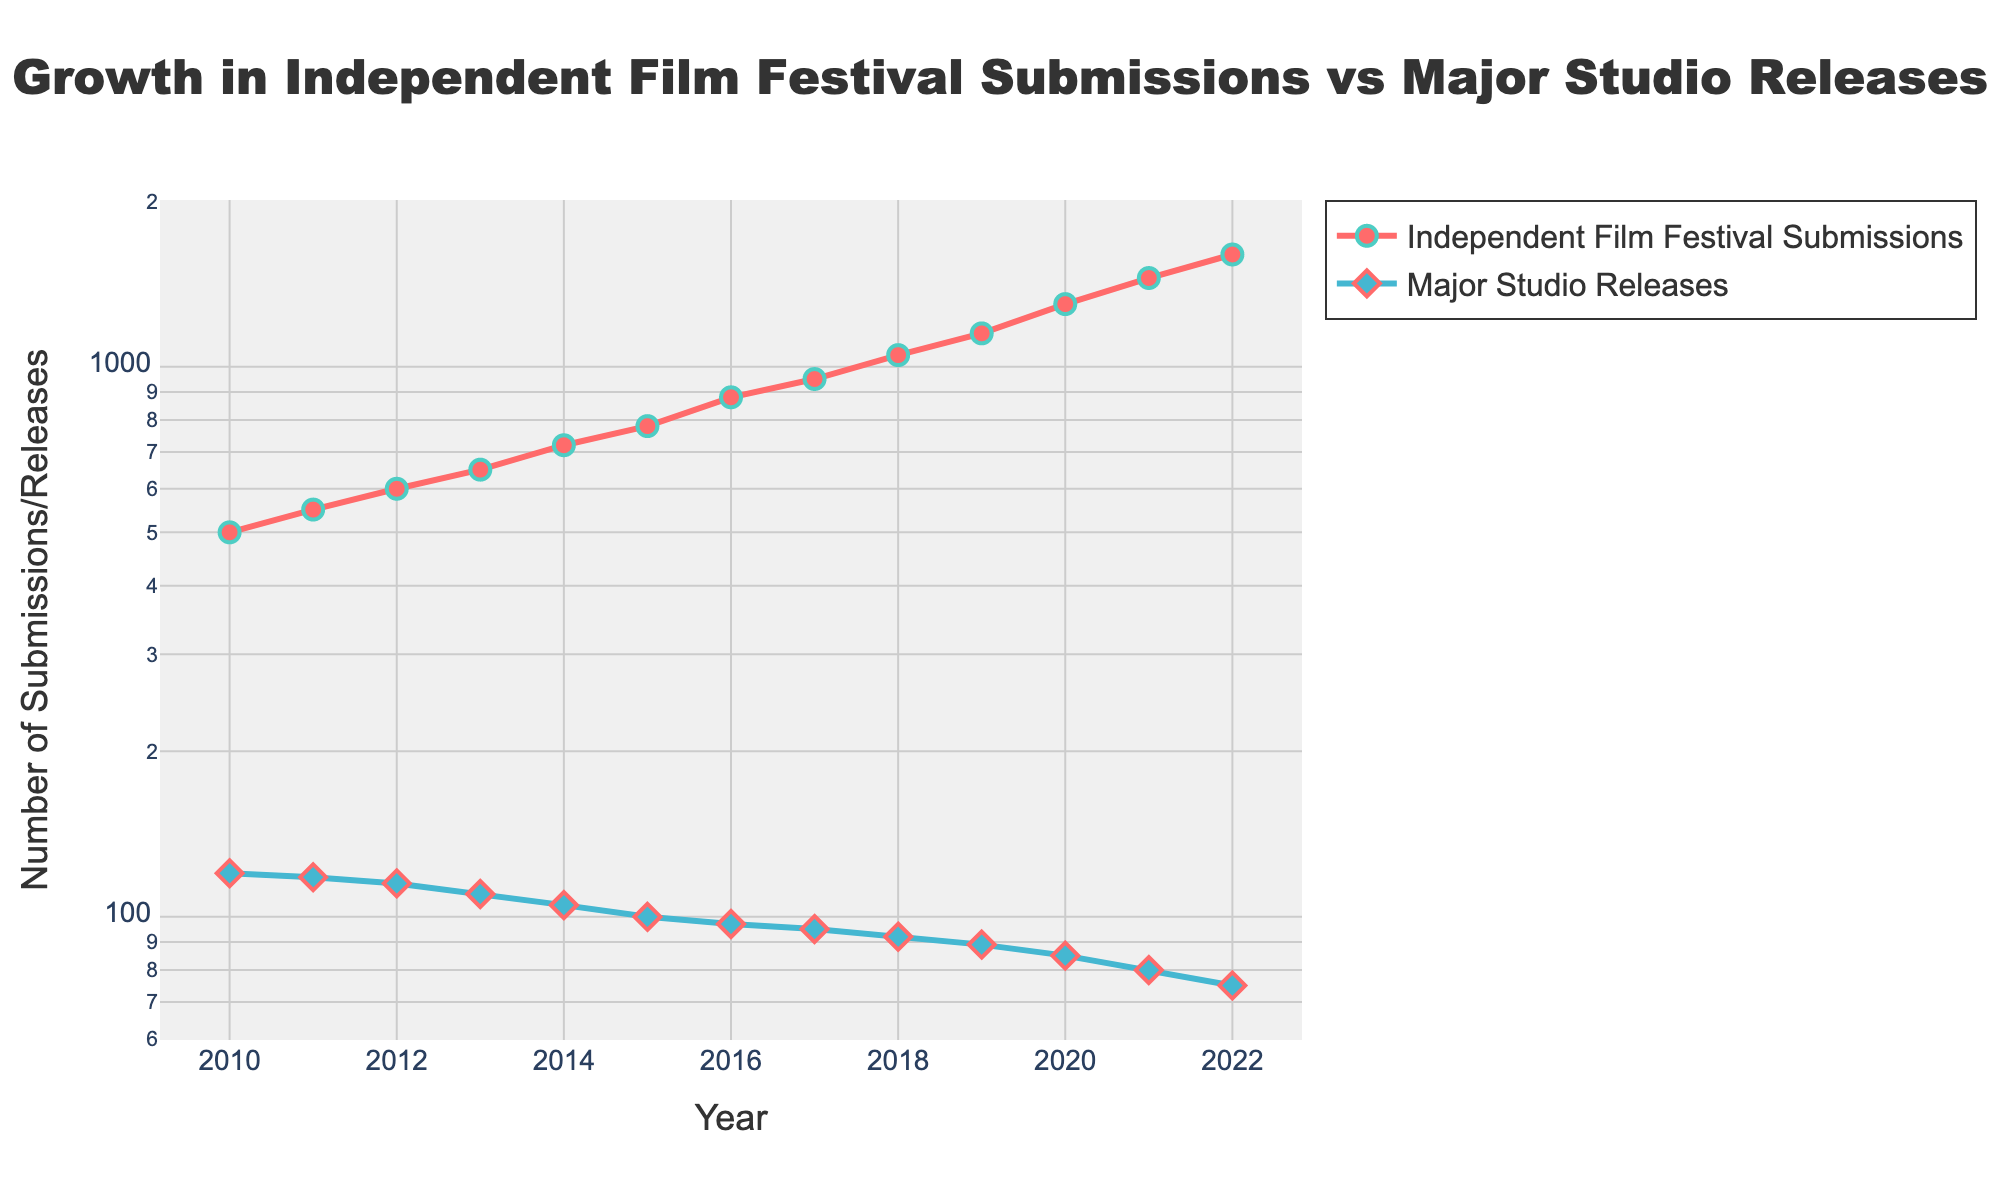How many data points represent the Independent Film Festival Submissions from 2010 to 2022? By counting the number of data points along the timeline from 2010 to 2022 for the Independent Film Festival Submissions, you can see there are 13 data points (one for each year).
Answer: 13 What color represents the Major Studio Releases in the plot? The color representing the Major Studio Releases is observed directly from the legend in the plot, which indicates a blue color.
Answer: Blue How does the number of submissions for Independent Film Festivals compare to Major Studio Releases in 2010? In the year 2010, the plot shows that Independent Film Festival Submissions are at 500, while Major Studio Releases are at 120, which means independent submissions are significantly higher.
Answer: Independent submissions are higher By what multiplicative factor did the Independent Film Festival Submissions increase from 2010 to 2022? To find the factor of increase, divide the data point of 2022 (1600 submissions) by the data point of 2010 (500 submissions). The calculation is 1600 ÷ 500 = 3.2.
Answer: 3.2 In which year did Major Studio Releases fall below 100? According to the plot, Major Studio Releases are below 100 starting from the year 2015.
Answer: 2015 What's the average annual increase in Independent Film Festival Submissions from 2010 to 2022? The total increase is found by subtracting 500 (2010) from 1600 (2022), resulting in 1100. There are 12 intervals (2022 - 2010), so the average increase per year is 1100 ÷ 12 ≈ 91.67.
Answer: 91.67 Which category shows a logarithmic scale increase in the y-axis? Observing the y-axis scale and the nature of exponential growth in the Independent Film Festival Submissions, it is evident that they are plotted on a logarithmic scale due to the exponential trend.
Answer: Independent Film Festival Submissions How much did Major Studio Releases decrease on average each year from 2010 to 2022? The total decrease is 120 (2010) - 75 (2022), which equals 45. Over 12 years, the average decrease per year is 45 ÷ 12 ≈ 3.75.
Answer: 3.75 Is there any year where the number of Major Studio Releases was equal to the number of Independent Film Festival Submissions? Checking each year on the plot, there is no instance where the number of Major Studio Releases equals the number of Independent Film Festival Submissions in any given year.
Answer: No What is the trend observed in the number of Independent Film Festival Submissions over the years 2010 to 2022? The trend for Independent Film Festival Submissions shows a consistent and exponential increase from 500 in 2010 to 1600 in 2022, indicating a significant upward trajectory.
Answer: Exponential increase 